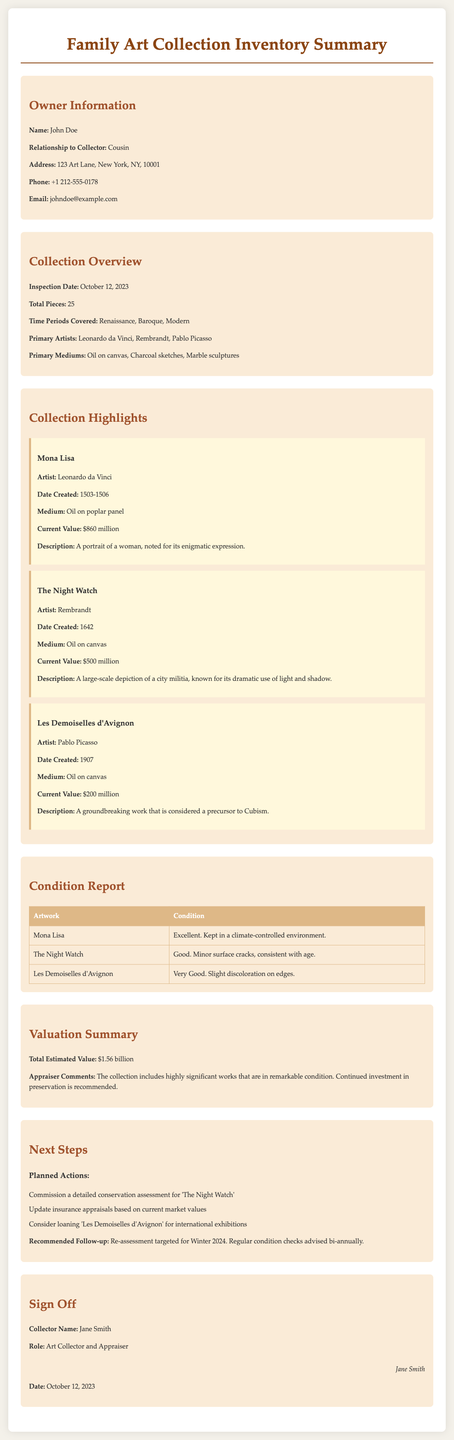what is the owner's name? The owner's name is provided in the owner information section, which is John Doe.
Answer: John Doe how many pieces are in the collection? The total number of pieces in the collection is stated as 25 in the collection overview.
Answer: 25 who created Les Demoiselles d'Avignon? The artist of Les Demoiselles d'Avignon is specified in the collection highlights, which is Pablo Picasso.
Answer: Pablo Picasso what is the current value of The Night Watch? The current value is listed in the collection highlights for The Night Watch, which is $500 million.
Answer: $500 million what is the condition of Mona Lisa? The condition of Mona Lisa is provided in the condition report, stating it is in excellent condition.
Answer: Excellent what are the time periods covered in the collection? The time periods covered are detailed in the collection overview, which includes Renaissance, Baroque, and Modern.
Answer: Renaissance, Baroque, Modern who is responsible for the next conservation assessment? The planned action for the conservation assessment is detailed in the next steps as being for The Night Watch.
Answer: The Night Watch what is the total estimated value of the collection? The total estimated value is mentioned in the valuation summary, which is $1.56 billion.
Answer: $1.56 billion when was the inspection date? The inspection date is specified in the collection overview as October 12, 2023.
Answer: October 12, 2023 